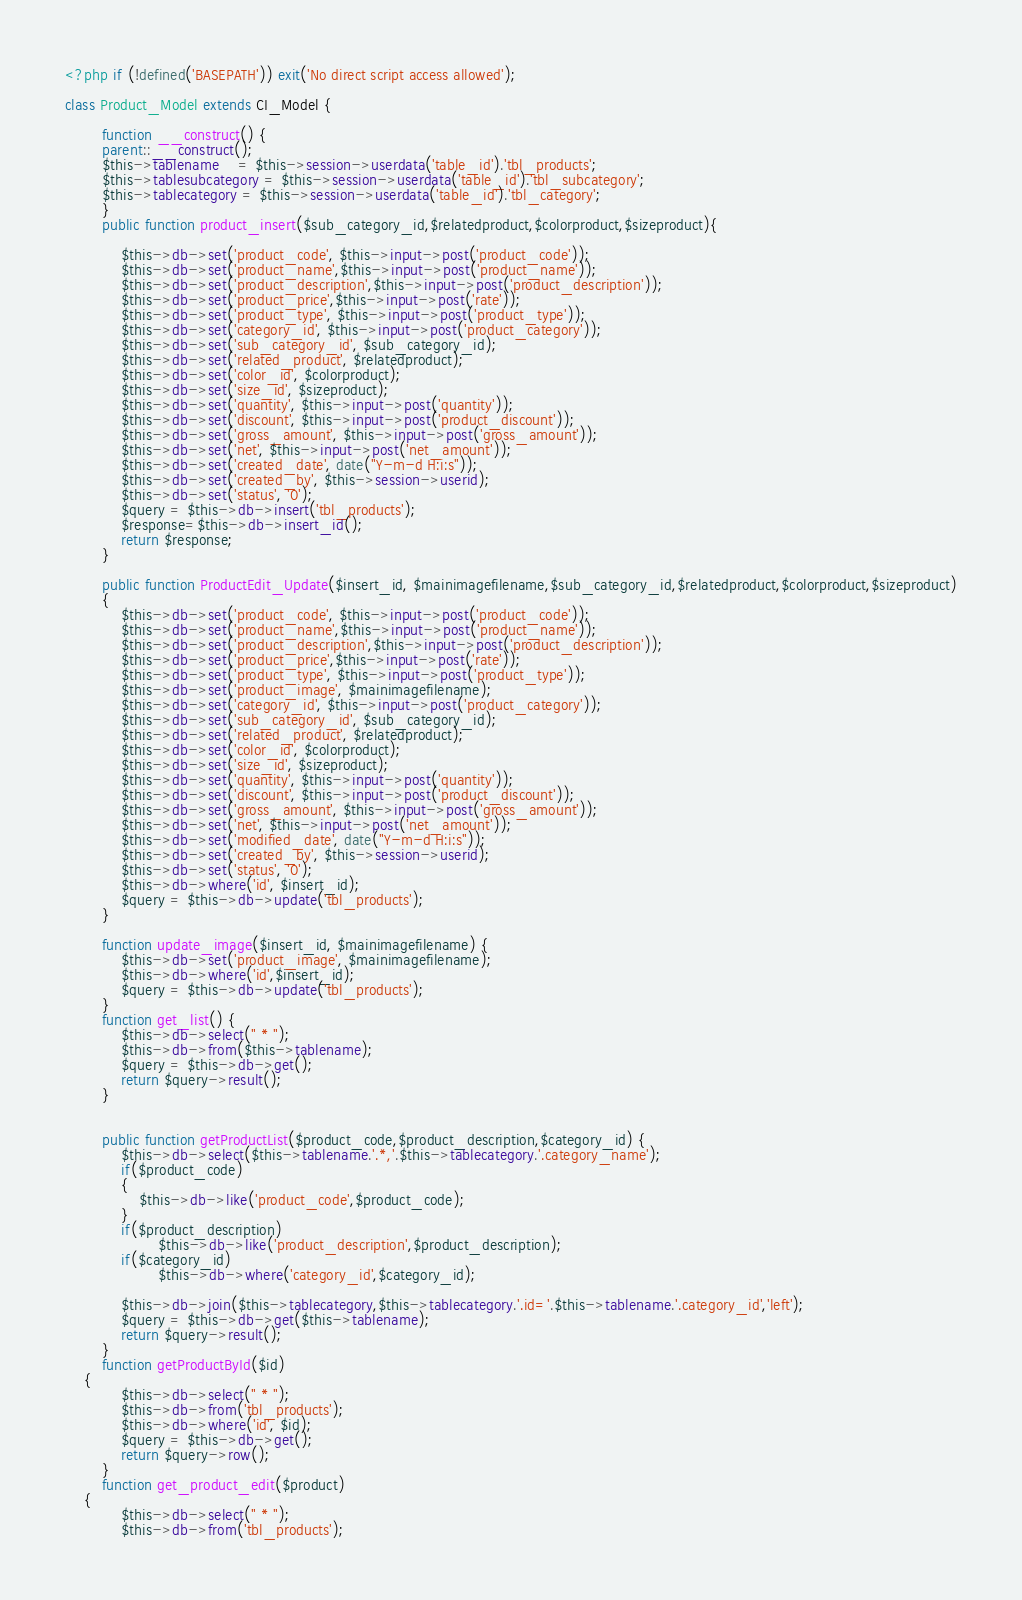Convert code to text. <code><loc_0><loc_0><loc_500><loc_500><_PHP_><?php if (!defined('BASEPATH')) exit('No direct script access allowed');

class Product_Model extends CI_Model {
    
        function __construct() {
        parent::__construct();
		$this->tablename	= $this->session->userdata('table_id').'tbl_products';
		$this->tablesubcategory = $this->session->userdata('table_id').'tbl_subcategory';
		$this->tablecategory = $this->session->userdata('table_id').'tbl_category';
        }
        public function product_insert($sub_category_id,$relatedproduct,$colorproduct,$sizeproduct){
            
            $this->db->set('product_code', $this->input->post('product_code'));
            $this->db->set('product_name',$this->input->post('product_name'));
            $this->db->set('product_description',$this->input->post('product_description'));  
            $this->db->set('product_price',$this->input->post('rate'));
            $this->db->set('product_type', $this->input->post('product_type'));
            $this->db->set('category_id', $this->input->post('product_category'));
            $this->db->set('sub_category_id', $sub_category_id);
            $this->db->set('related_product', $relatedproduct);
            $this->db->set('color_id', $colorproduct);
            $this->db->set('size_id', $sizeproduct);
            $this->db->set('quantity', $this->input->post('quantity'));
            $this->db->set('discount', $this->input->post('product_discount'));
            $this->db->set('gross_amount', $this->input->post('gross_amount'));
            $this->db->set('net', $this->input->post('net_amount'));
            $this->db->set('created_date', date("Y-m-d H:i:s"));
            $this->db->set('created_by', $this->session->userid);
            $this->db->set('status', '0');
            $query = $this->db->insert('tbl_products');
            $response=$this->db->insert_id();
            return $response;
        }
        
        public function ProductEdit_Update($insert_id, $mainimagefilename,$sub_category_id,$relatedproduct,$colorproduct,$sizeproduct)
        {
            $this->db->set('product_code', $this->input->post('product_code'));
            $this->db->set('product_name',$this->input->post('product_name'));
            $this->db->set('product_description',$this->input->post('product_description'));  
            $this->db->set('product_price',$this->input->post('rate'));
            $this->db->set('product_type', $this->input->post('product_type'));
            $this->db->set('product_image', $mainimagefilename);
            $this->db->set('category_id', $this->input->post('product_category'));
            $this->db->set('sub_category_id', $sub_category_id);
            $this->db->set('related_product', $relatedproduct);
            $this->db->set('color_id', $colorproduct);
            $this->db->set('size_id', $sizeproduct);
            $this->db->set('quantity', $this->input->post('quantity'));
            $this->db->set('discount', $this->input->post('product_discount'));
            $this->db->set('gross_amount', $this->input->post('gross_amount'));
            $this->db->set('net', $this->input->post('net_amount'));
            $this->db->set('modified_date', date("Y-m-d H:i:s"));
            $this->db->set('created_by', $this->session->userid);
            $this->db->set('status', '0');
            $this->db->where('id', $insert_id);
            $query = $this->db->update('tbl_products');
        }
        
        function update_image($insert_id, $mainimagefilename) {
            $this->db->set('product_image', $mainimagefilename);
            $this->db->where('id',$insert_id);
            $query = $this->db->update('tbl_products');
        }
        function get_list() {
            $this->db->select(" * ");
            $this->db->from($this->tablename);
            $query = $this->db->get();
            return $query->result();
        }
        
        
        public function getProductList($product_code,$product_description,$category_id) {
            $this->db->select($this->tablename.'.*,'.$this->tablecategory.'.category_name');
            if($product_code)
            {
                $this->db->like('product_code',$product_code);
            }
            if($product_description)
                    $this->db->like('product_description',$product_description);
            if($category_id)
                    $this->db->where('category_id',$category_id);

            $this->db->join($this->tablecategory,$this->tablecategory.'.id='.$this->tablename.'.category_id','left');
            $query = $this->db->get($this->tablename);
            return $query->result();
        }
        function getProductById($id)
	{
            $this->db->select(" * ");
            $this->db->from('tbl_products');
            $this->db->where('id', $id);
            $query = $this->db->get();
            return $query->row();
        }
        function get_product_edit($product)
	{
            $this->db->select(" * ");
            $this->db->from('tbl_products');</code> 